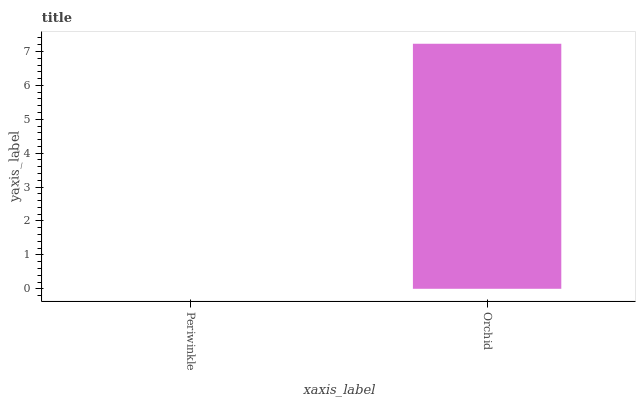Is Periwinkle the minimum?
Answer yes or no. Yes. Is Orchid the maximum?
Answer yes or no. Yes. Is Orchid the minimum?
Answer yes or no. No. Is Orchid greater than Periwinkle?
Answer yes or no. Yes. Is Periwinkle less than Orchid?
Answer yes or no. Yes. Is Periwinkle greater than Orchid?
Answer yes or no. No. Is Orchid less than Periwinkle?
Answer yes or no. No. Is Orchid the high median?
Answer yes or no. Yes. Is Periwinkle the low median?
Answer yes or no. Yes. Is Periwinkle the high median?
Answer yes or no. No. Is Orchid the low median?
Answer yes or no. No. 